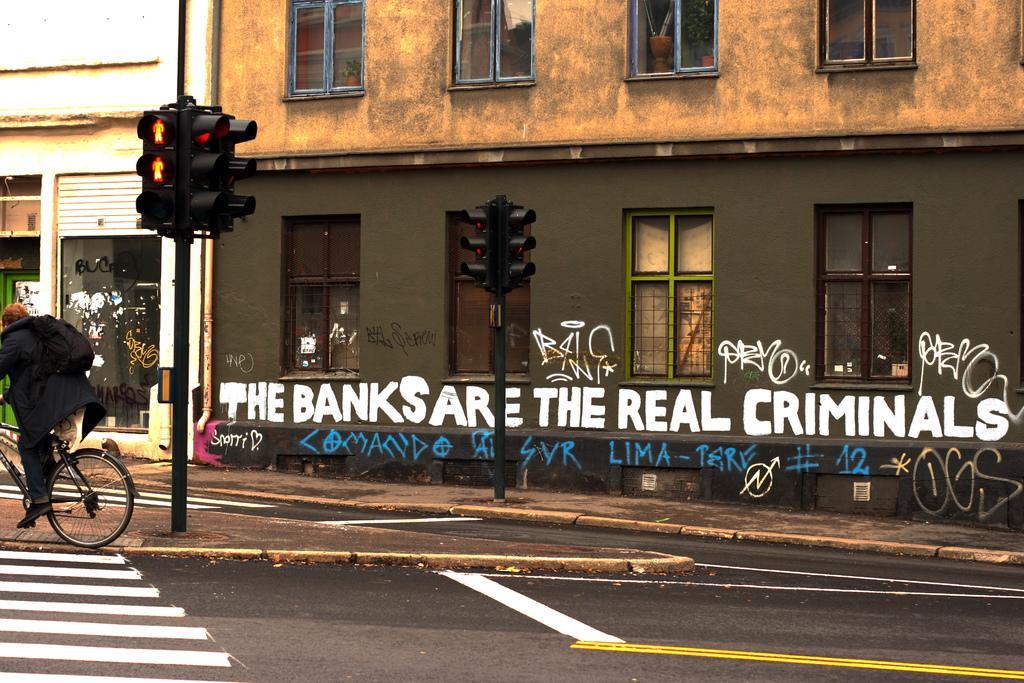Could you give a brief overview of what you see in this image? In this image I can see a building, in front of building there are two traffic signal poles, person riding on bicycle , wearing a bag visible on the left , there are some zebra cross lines visible in the bottom left , at the bottom there is a road, on the wall there is a text, in the top left I can see another building. 